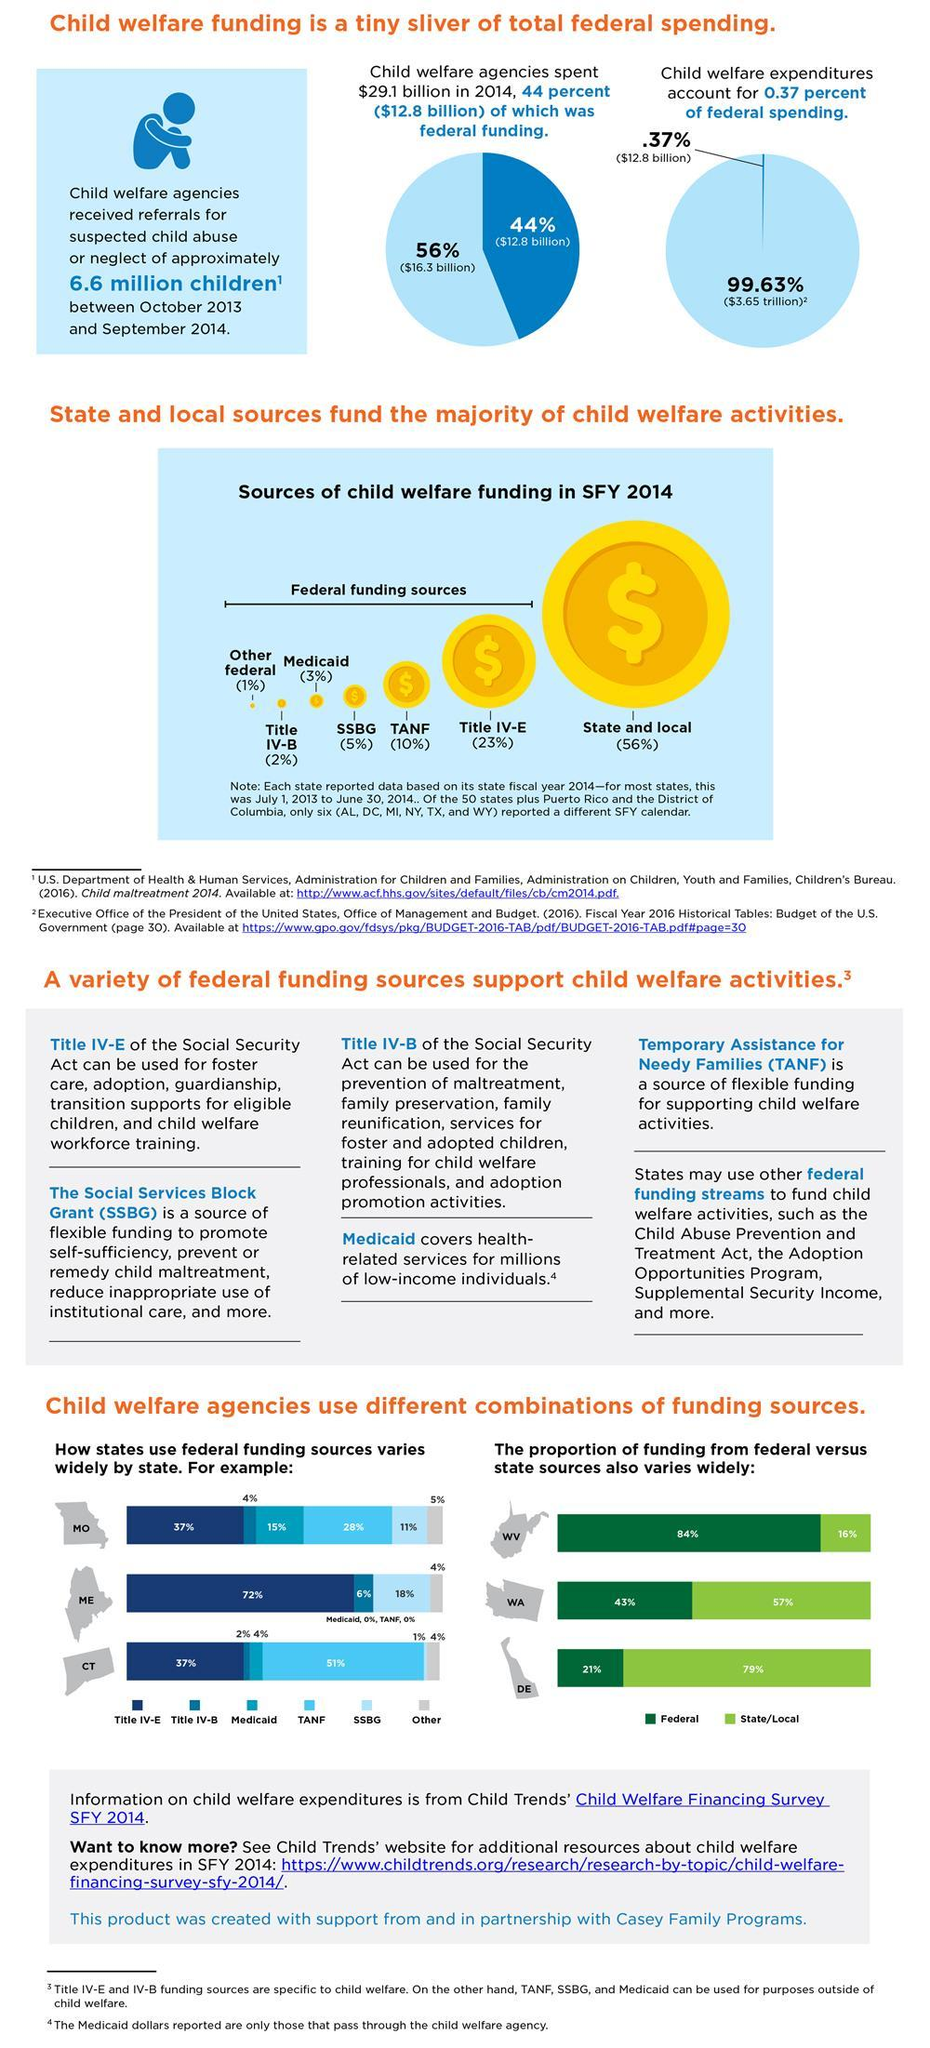What is the total amount of federal expenditures excluding Child welfare in 2014?
Answer the question with a short phrase. $3.65 trillion Which type of funding source does Delaware use for Child welfare the most? State/Local Who contributed to the 56% of child welfare funding in 2014? State and local funding sources How much did Medicaid contribute? 3% Which federal source contributed the most for child welfare in 2014? Title IV-E Which federal funding source does Maine use for Child welfare the most? Title IV-E Which federal funding source does Connecticut use for Child welfare the most? TANF How much did Temporary Assistance for Needy Families contribute for Child welfare funding? 10% Which type of funding source does West Virginia use for Child welfare the most? Federal How much of child welfare funding was not federal funding in 2014? $16.3 billion 